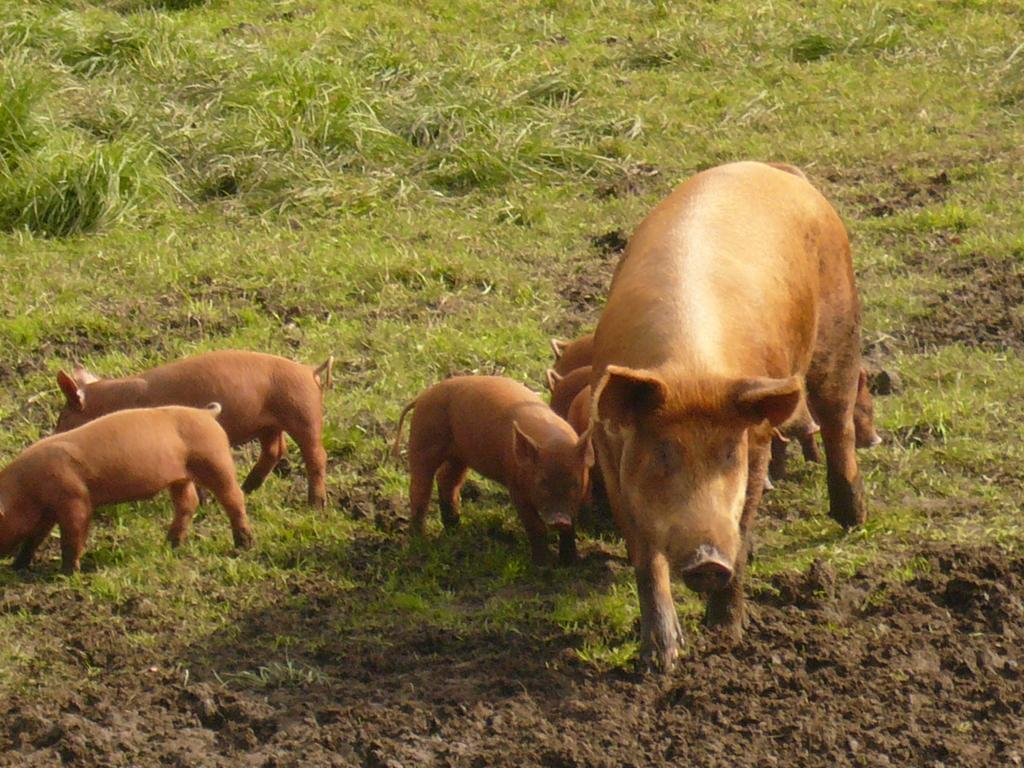What animals are present in the image? There are pigs in the image. What color are the pigs? The pigs are brown in color. What type of surface can be seen in the image? There is a ground visible in the image. Can you see a kite flying in the image? A: There is no kite present in the image. 